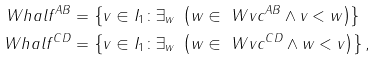Convert formula to latex. <formula><loc_0><loc_0><loc_500><loc_500>\ W h a l f ^ { A B } & = \left \{ v \in I _ { 1 } \colon \exists _ { w } \ \left ( w \in \ W v c ^ { A B } \wedge v < w \right ) \right \} \\ \ W h a l f ^ { C D } & = \left \{ v \in I _ { 1 } \colon \exists _ { w } \ \left ( w \in \ W v c ^ { C D } \wedge w < v \right ) \right \} ,</formula> 